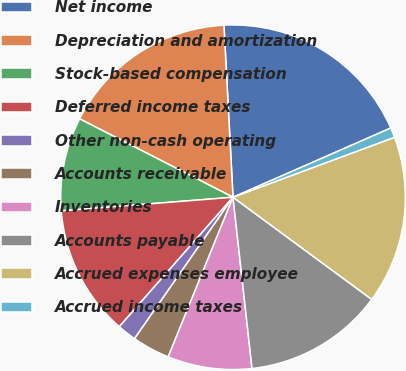Convert chart. <chart><loc_0><loc_0><loc_500><loc_500><pie_chart><fcel>Net income<fcel>Depreciation and amortization<fcel>Stock-based compensation<fcel>Deferred income taxes<fcel>Other non-cash operating<fcel>Accounts receivable<fcel>Inventories<fcel>Accounts payable<fcel>Accrued expenses employee<fcel>Accrued income taxes<nl><fcel>19.26%<fcel>16.64%<fcel>8.78%<fcel>12.27%<fcel>1.79%<fcel>3.54%<fcel>7.9%<fcel>13.14%<fcel>15.76%<fcel>0.92%<nl></chart> 